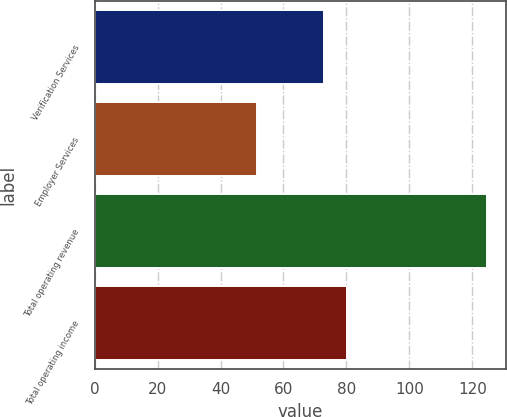Convert chart to OTSL. <chart><loc_0><loc_0><loc_500><loc_500><bar_chart><fcel>Verification Services<fcel>Employer Services<fcel>Total operating revenue<fcel>Total operating income<nl><fcel>72.9<fcel>51.6<fcel>124.5<fcel>80.19<nl></chart> 